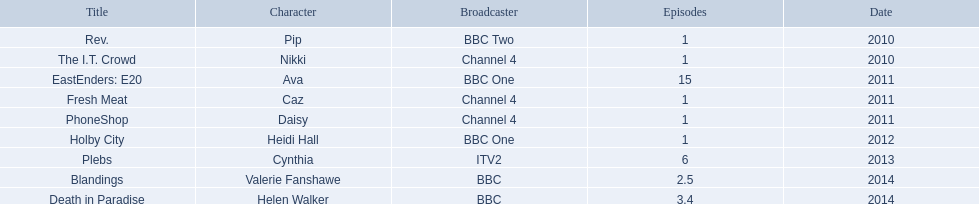How many episodes of rev. included sophie colquhoun? 1. What role did she have in phoneshop? Daisy. Which character did she play on itv2? Cynthia. What were her acting roles? Pip, Nikki, Ava, Caz, Daisy, Heidi Hall, Cynthia, Valerie Fanshawe, Helen Walker. Which broadcasters showcased her talent? BBC Two, Channel 4, BBC One, Channel 4, Channel 4, BBC One, ITV2, BBC, BBC. What characters did she play on itv2? Cynthia. 